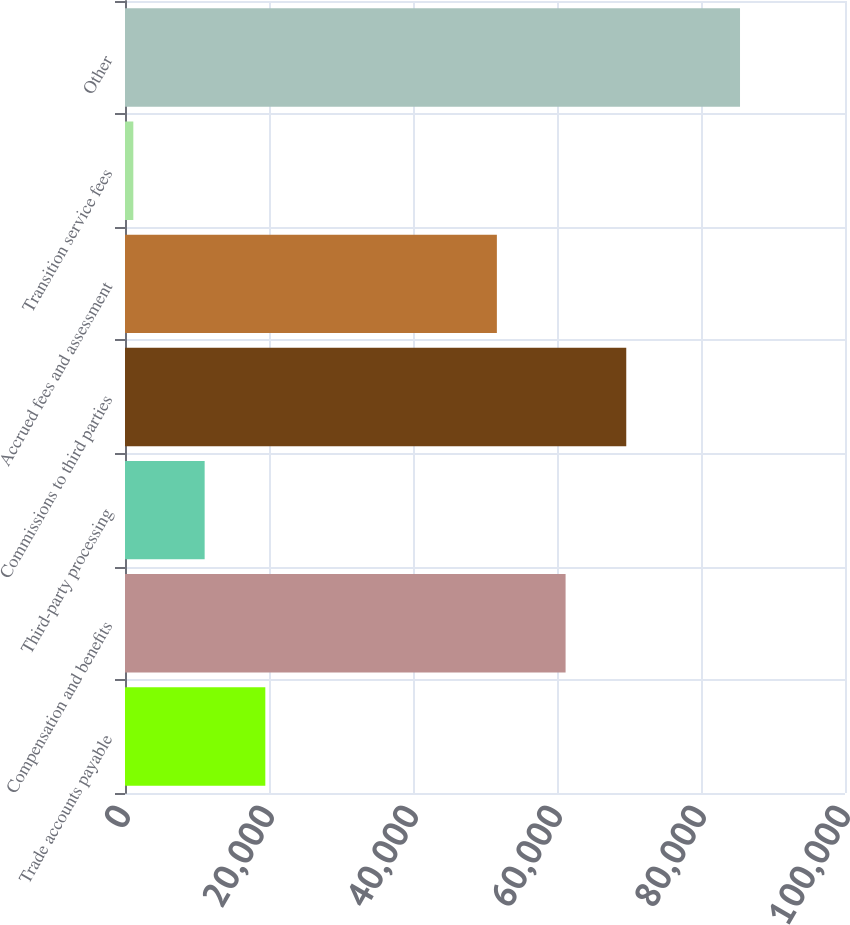<chart> <loc_0><loc_0><loc_500><loc_500><bar_chart><fcel>Trade accounts payable<fcel>Compensation and benefits<fcel>Third-party processing<fcel>Commissions to third parties<fcel>Accrued fees and assessment<fcel>Transition service fees<fcel>Other<nl><fcel>19488.3<fcel>61193<fcel>11062<fcel>69619.3<fcel>51649<fcel>1156<fcel>85419<nl></chart> 